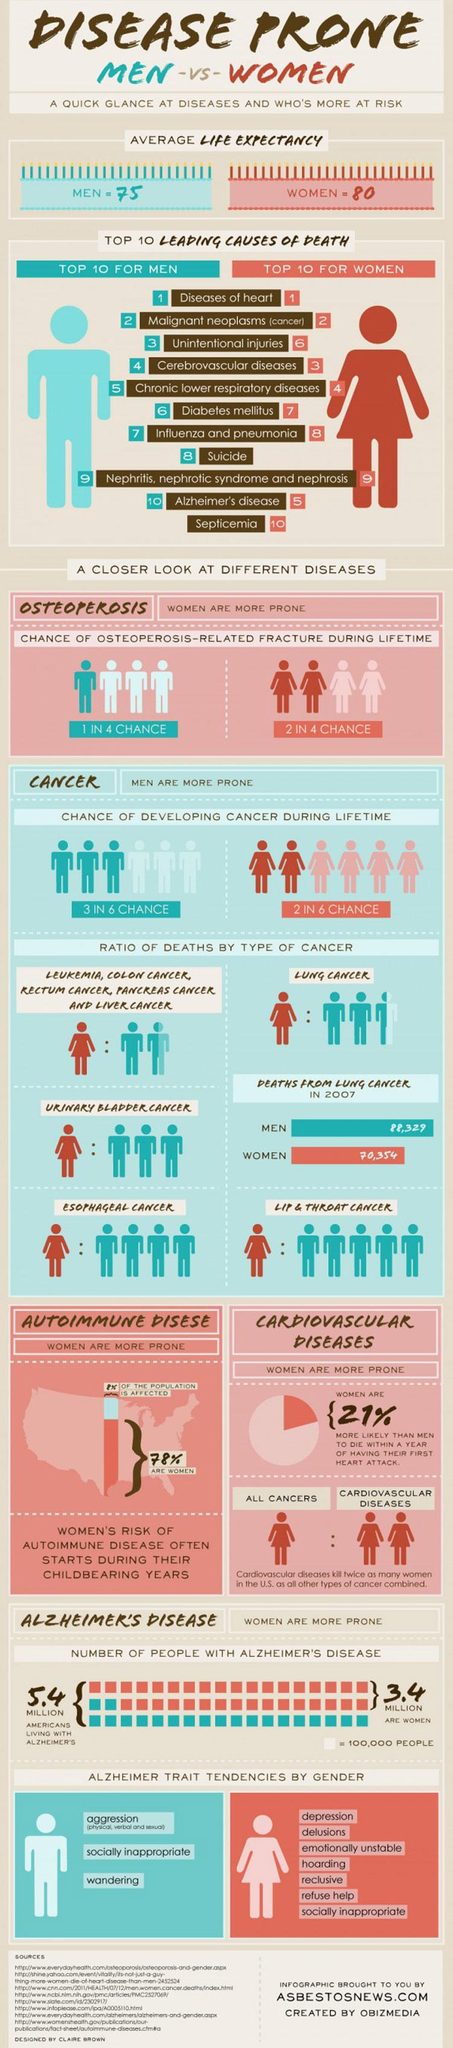List a handful of essential elements in this visual. It is estimated that approximately 50% of women will experience an osteoporosis-related fracture during their lifetime. Suicide is the leading cause of death in men and not in women. The life expectancy of women is expected to be approximately 5 years longer than that of men, on average, when compared over a certain period of time. Women generally have a higher life expectancy than men. Men with Alzheimer's disease may exhibit traits such as aggression, socially inappropriate behavior, and a tendency to wander. 